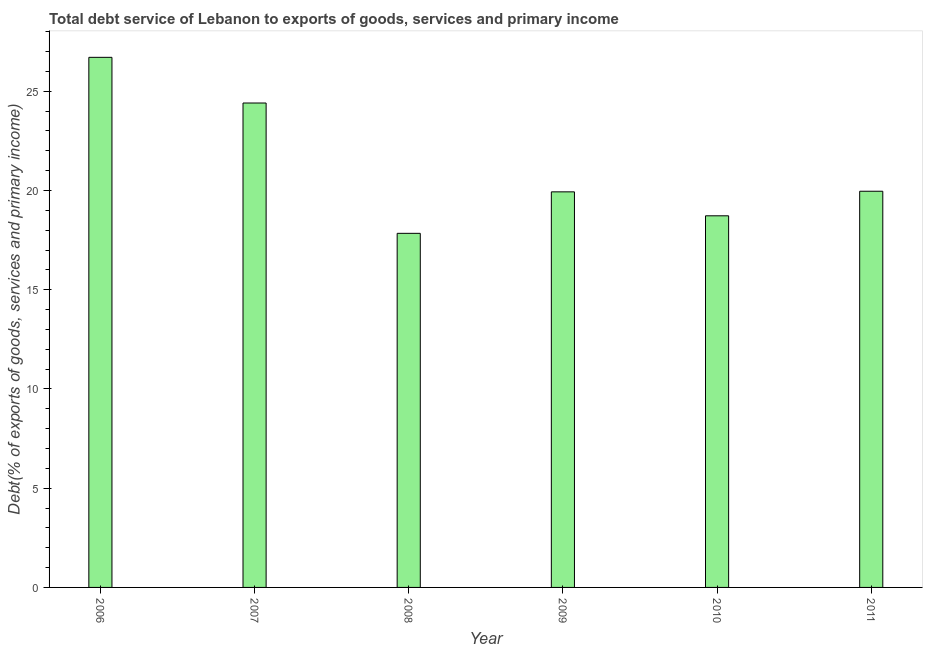Does the graph contain any zero values?
Offer a terse response. No. What is the title of the graph?
Your answer should be compact. Total debt service of Lebanon to exports of goods, services and primary income. What is the label or title of the Y-axis?
Offer a very short reply. Debt(% of exports of goods, services and primary income). What is the total debt service in 2006?
Provide a succinct answer. 26.71. Across all years, what is the maximum total debt service?
Keep it short and to the point. 26.71. Across all years, what is the minimum total debt service?
Offer a terse response. 17.84. What is the sum of the total debt service?
Provide a succinct answer. 127.57. What is the difference between the total debt service in 2009 and 2011?
Give a very brief answer. -0.03. What is the average total debt service per year?
Your response must be concise. 21.26. What is the median total debt service?
Provide a succinct answer. 19.95. In how many years, is the total debt service greater than 11 %?
Provide a succinct answer. 6. What is the ratio of the total debt service in 2006 to that in 2010?
Provide a short and direct response. 1.43. Is the total debt service in 2009 less than that in 2010?
Offer a very short reply. No. Is the difference between the total debt service in 2007 and 2009 greater than the difference between any two years?
Your response must be concise. No. What is the difference between the highest and the second highest total debt service?
Offer a very short reply. 2.3. Is the sum of the total debt service in 2007 and 2008 greater than the maximum total debt service across all years?
Your answer should be compact. Yes. What is the difference between the highest and the lowest total debt service?
Make the answer very short. 8.87. In how many years, is the total debt service greater than the average total debt service taken over all years?
Provide a short and direct response. 2. Are the values on the major ticks of Y-axis written in scientific E-notation?
Your response must be concise. No. What is the Debt(% of exports of goods, services and primary income) of 2006?
Ensure brevity in your answer.  26.71. What is the Debt(% of exports of goods, services and primary income) in 2007?
Make the answer very short. 24.41. What is the Debt(% of exports of goods, services and primary income) in 2008?
Offer a terse response. 17.84. What is the Debt(% of exports of goods, services and primary income) of 2009?
Provide a short and direct response. 19.93. What is the Debt(% of exports of goods, services and primary income) in 2010?
Provide a succinct answer. 18.72. What is the Debt(% of exports of goods, services and primary income) in 2011?
Keep it short and to the point. 19.96. What is the difference between the Debt(% of exports of goods, services and primary income) in 2006 and 2007?
Your answer should be very brief. 2.3. What is the difference between the Debt(% of exports of goods, services and primary income) in 2006 and 2008?
Ensure brevity in your answer.  8.87. What is the difference between the Debt(% of exports of goods, services and primary income) in 2006 and 2009?
Offer a very short reply. 6.78. What is the difference between the Debt(% of exports of goods, services and primary income) in 2006 and 2010?
Provide a short and direct response. 7.98. What is the difference between the Debt(% of exports of goods, services and primary income) in 2006 and 2011?
Your answer should be very brief. 6.75. What is the difference between the Debt(% of exports of goods, services and primary income) in 2007 and 2008?
Your answer should be compact. 6.57. What is the difference between the Debt(% of exports of goods, services and primary income) in 2007 and 2009?
Keep it short and to the point. 4.48. What is the difference between the Debt(% of exports of goods, services and primary income) in 2007 and 2010?
Offer a very short reply. 5.68. What is the difference between the Debt(% of exports of goods, services and primary income) in 2007 and 2011?
Make the answer very short. 4.45. What is the difference between the Debt(% of exports of goods, services and primary income) in 2008 and 2009?
Make the answer very short. -2.09. What is the difference between the Debt(% of exports of goods, services and primary income) in 2008 and 2010?
Your answer should be very brief. -0.88. What is the difference between the Debt(% of exports of goods, services and primary income) in 2008 and 2011?
Provide a short and direct response. -2.12. What is the difference between the Debt(% of exports of goods, services and primary income) in 2009 and 2010?
Give a very brief answer. 1.21. What is the difference between the Debt(% of exports of goods, services and primary income) in 2009 and 2011?
Offer a very short reply. -0.03. What is the difference between the Debt(% of exports of goods, services and primary income) in 2010 and 2011?
Provide a succinct answer. -1.24. What is the ratio of the Debt(% of exports of goods, services and primary income) in 2006 to that in 2007?
Your answer should be very brief. 1.09. What is the ratio of the Debt(% of exports of goods, services and primary income) in 2006 to that in 2008?
Make the answer very short. 1.5. What is the ratio of the Debt(% of exports of goods, services and primary income) in 2006 to that in 2009?
Offer a terse response. 1.34. What is the ratio of the Debt(% of exports of goods, services and primary income) in 2006 to that in 2010?
Ensure brevity in your answer.  1.43. What is the ratio of the Debt(% of exports of goods, services and primary income) in 2006 to that in 2011?
Your response must be concise. 1.34. What is the ratio of the Debt(% of exports of goods, services and primary income) in 2007 to that in 2008?
Offer a terse response. 1.37. What is the ratio of the Debt(% of exports of goods, services and primary income) in 2007 to that in 2009?
Keep it short and to the point. 1.23. What is the ratio of the Debt(% of exports of goods, services and primary income) in 2007 to that in 2010?
Ensure brevity in your answer.  1.3. What is the ratio of the Debt(% of exports of goods, services and primary income) in 2007 to that in 2011?
Offer a terse response. 1.22. What is the ratio of the Debt(% of exports of goods, services and primary income) in 2008 to that in 2009?
Ensure brevity in your answer.  0.9. What is the ratio of the Debt(% of exports of goods, services and primary income) in 2008 to that in 2010?
Give a very brief answer. 0.95. What is the ratio of the Debt(% of exports of goods, services and primary income) in 2008 to that in 2011?
Give a very brief answer. 0.89. What is the ratio of the Debt(% of exports of goods, services and primary income) in 2009 to that in 2010?
Offer a very short reply. 1.06. What is the ratio of the Debt(% of exports of goods, services and primary income) in 2009 to that in 2011?
Your answer should be very brief. 1. What is the ratio of the Debt(% of exports of goods, services and primary income) in 2010 to that in 2011?
Provide a short and direct response. 0.94. 